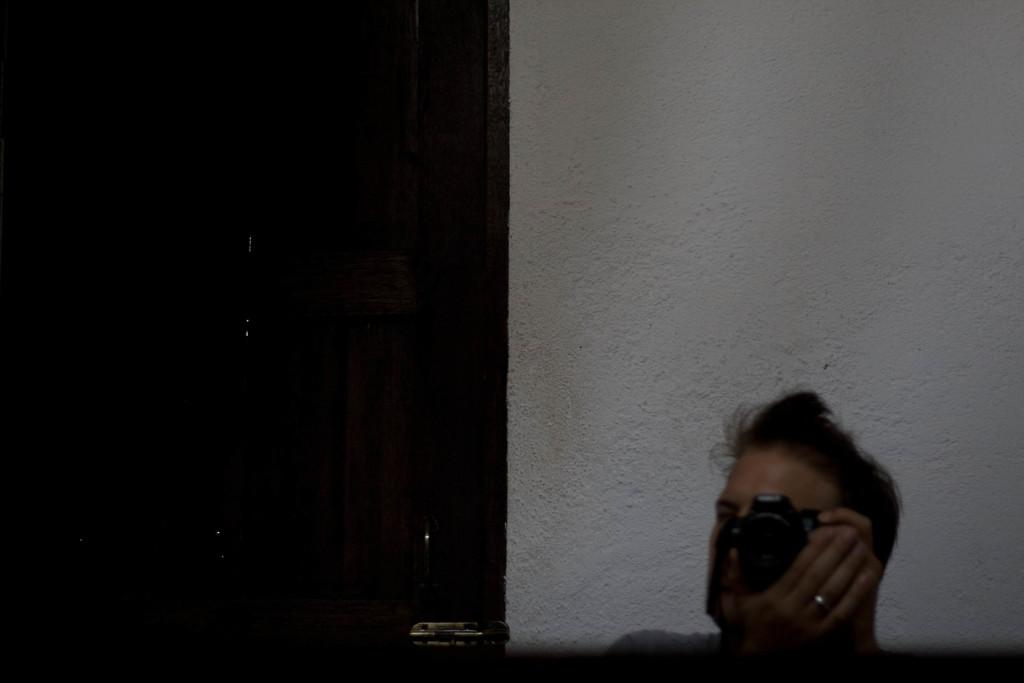What is the person in the bottom right side of the image doing? The person is holding a camera in the bottom right side of the image. What can be seen in the background of the image? There is a wall and a door in the background of the image. How many brothers are standing next to the lamp in the image? There is no lamp or brothers present in the image. 